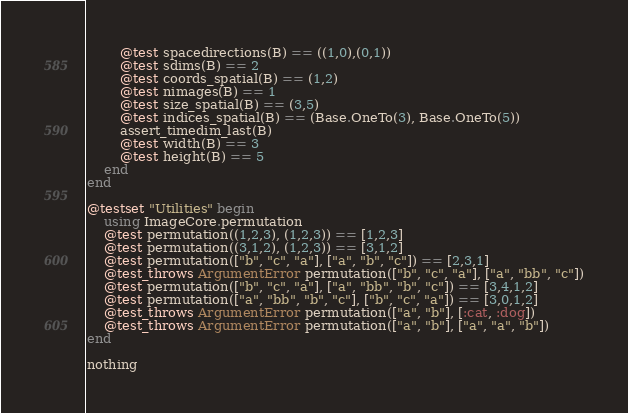<code> <loc_0><loc_0><loc_500><loc_500><_Julia_>        @test spacedirections(B) == ((1,0),(0,1))
        @test sdims(B) == 2
        @test coords_spatial(B) == (1,2)
        @test nimages(B) == 1
        @test size_spatial(B) == (3,5)
        @test indices_spatial(B) == (Base.OneTo(3), Base.OneTo(5))
        assert_timedim_last(B)
        @test width(B) == 3
        @test height(B) == 5
    end
end

@testset "Utilities" begin
    using ImageCore.permutation
    @test permutation((1,2,3), (1,2,3)) == [1,2,3]
    @test permutation((3,1,2), (1,2,3)) == [3,1,2]
    @test permutation(["b", "c", "a"], ["a", "b", "c"]) == [2,3,1]
    @test_throws ArgumentError permutation(["b", "c", "a"], ["a", "bb", "c"])
    @test permutation(["b", "c", "a"], ["a", "bb", "b", "c"]) == [3,4,1,2]
    @test permutation(["a", "bb", "b", "c"], ["b", "c", "a"]) == [3,0,1,2]
    @test_throws ArgumentError permutation(["a", "b"], [:cat, :dog])
    @test_throws ArgumentError permutation(["a", "b"], ["a", "a", "b"])
end

nothing
</code> 